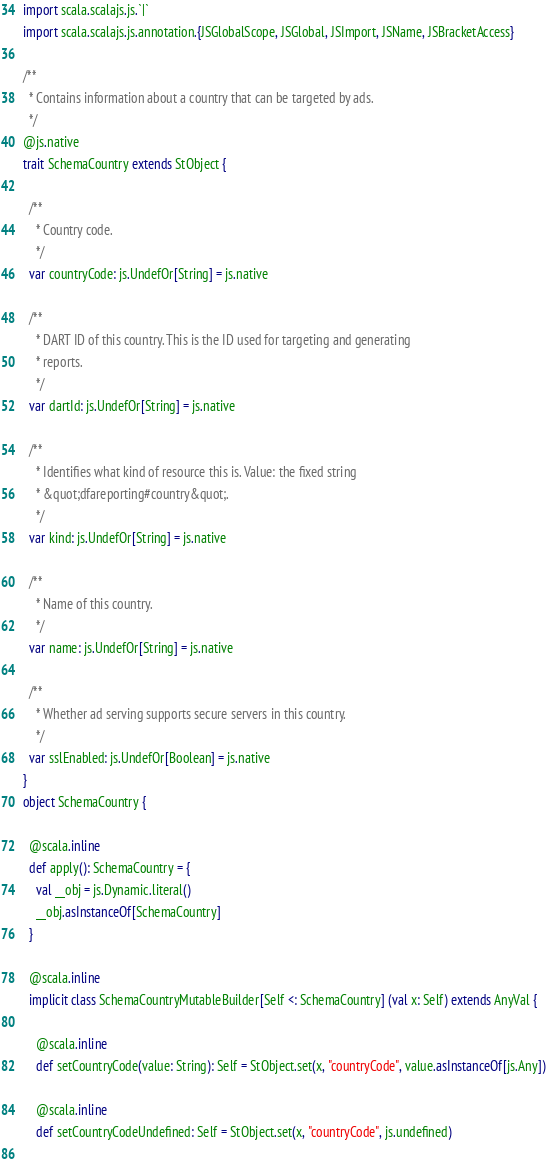<code> <loc_0><loc_0><loc_500><loc_500><_Scala_>import scala.scalajs.js.`|`
import scala.scalajs.js.annotation.{JSGlobalScope, JSGlobal, JSImport, JSName, JSBracketAccess}

/**
  * Contains information about a country that can be targeted by ads.
  */
@js.native
trait SchemaCountry extends StObject {
  
  /**
    * Country code.
    */
  var countryCode: js.UndefOr[String] = js.native
  
  /**
    * DART ID of this country. This is the ID used for targeting and generating
    * reports.
    */
  var dartId: js.UndefOr[String] = js.native
  
  /**
    * Identifies what kind of resource this is. Value: the fixed string
    * &quot;dfareporting#country&quot;.
    */
  var kind: js.UndefOr[String] = js.native
  
  /**
    * Name of this country.
    */
  var name: js.UndefOr[String] = js.native
  
  /**
    * Whether ad serving supports secure servers in this country.
    */
  var sslEnabled: js.UndefOr[Boolean] = js.native
}
object SchemaCountry {
  
  @scala.inline
  def apply(): SchemaCountry = {
    val __obj = js.Dynamic.literal()
    __obj.asInstanceOf[SchemaCountry]
  }
  
  @scala.inline
  implicit class SchemaCountryMutableBuilder[Self <: SchemaCountry] (val x: Self) extends AnyVal {
    
    @scala.inline
    def setCountryCode(value: String): Self = StObject.set(x, "countryCode", value.asInstanceOf[js.Any])
    
    @scala.inline
    def setCountryCodeUndefined: Self = StObject.set(x, "countryCode", js.undefined)
    </code> 